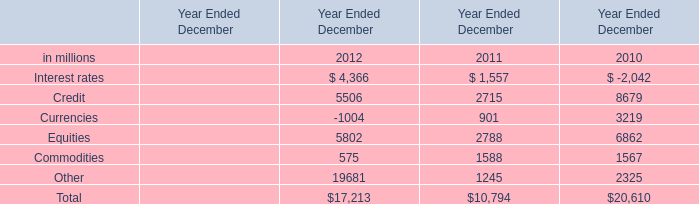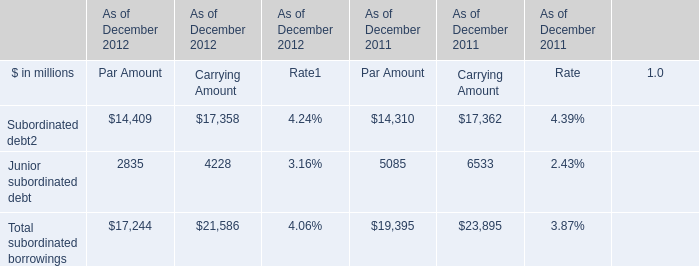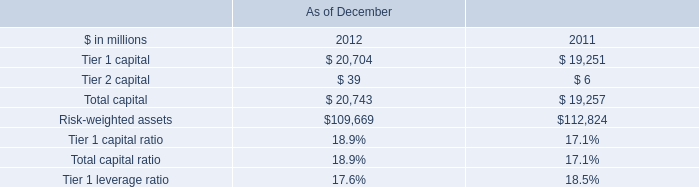What is the average amount of Credit of Year Ended December 2010, and Subordinated debt of As of December 2011 Carrying Amount ? 
Computations: ((8679.0 + 17362.0) / 2)
Answer: 13020.5. 